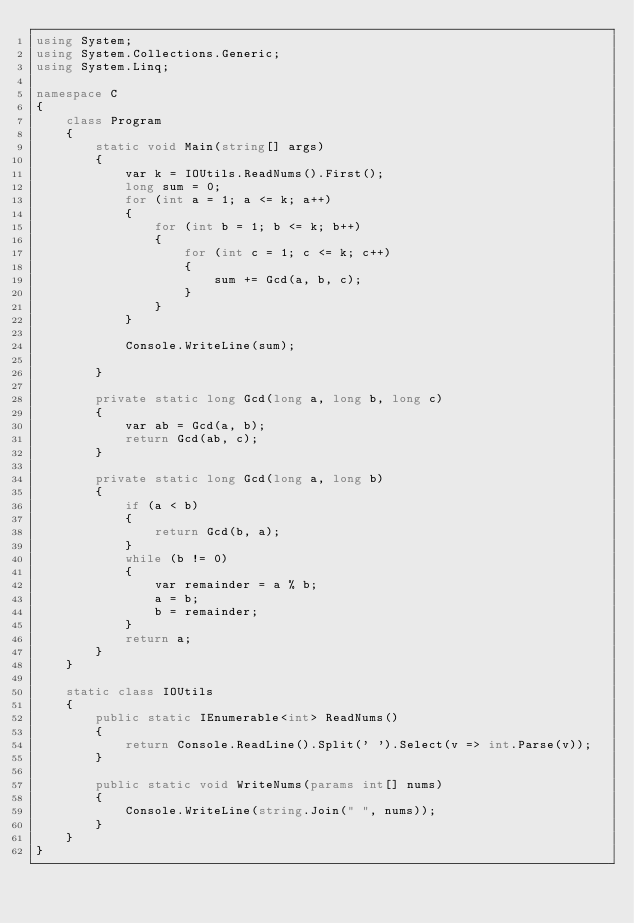Convert code to text. <code><loc_0><loc_0><loc_500><loc_500><_C#_>using System;
using System.Collections.Generic;
using System.Linq;

namespace C
{
    class Program
    {
        static void Main(string[] args)
        {
            var k = IOUtils.ReadNums().First();
            long sum = 0;
            for (int a = 1; a <= k; a++)
            {
                for (int b = 1; b <= k; b++)
                {
                    for (int c = 1; c <= k; c++)
                    {
                        sum += Gcd(a, b, c);
                    }
                }
            }

            Console.WriteLine(sum);

        }

        private static long Gcd(long a, long b, long c)
        {
            var ab = Gcd(a, b);
            return Gcd(ab, c);
        }

        private static long Gcd(long a, long b)
        {
            if (a < b)
            {
                return Gcd(b, a);
            }
            while (b != 0)
            {
                var remainder = a % b;
                a = b;
                b = remainder;
            }
            return a;
        }
    }

    static class IOUtils
    {
        public static IEnumerable<int> ReadNums()
        {
            return Console.ReadLine().Split(' ').Select(v => int.Parse(v));
        }

        public static void WriteNums(params int[] nums)
        {
            Console.WriteLine(string.Join(" ", nums));
        }
    }
}
</code> 